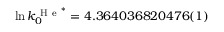Convert formula to latex. <formula><loc_0><loc_0><loc_500><loc_500>\ln k _ { 0 } ^ { H e ^ { * } } = 4 . 3 6 4 0 3 6 8 2 0 4 7 6 ( 1 )</formula> 